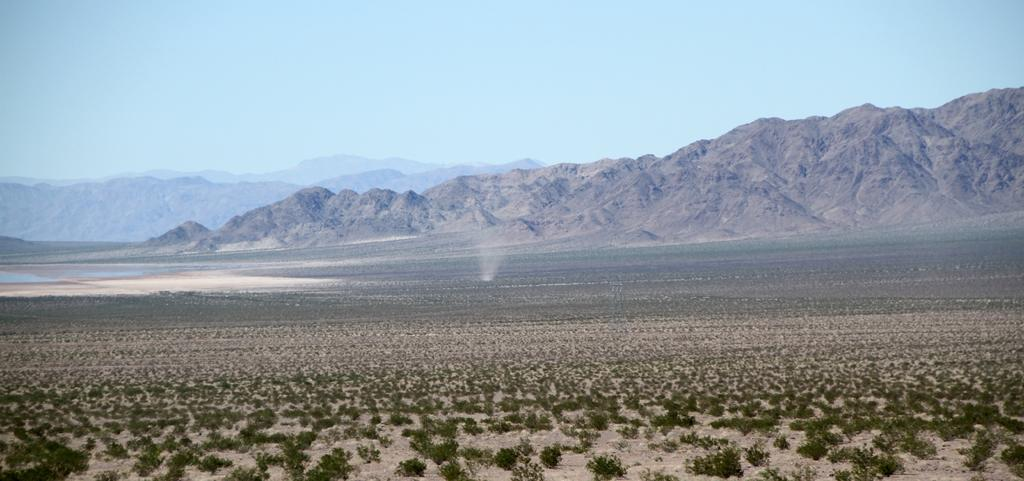What objects are on the ground in the image? There are planets on the ground in the image. What type of natural formation can be seen in the image? There are mountains visible in the image. What is visible in the background of the image? The sky is visible in the background of the image. What type of animal can be seen working on the mountains in the image? There are no animals or work-related activities depicted in the image. The image features planets on the ground and mountains in the background. 